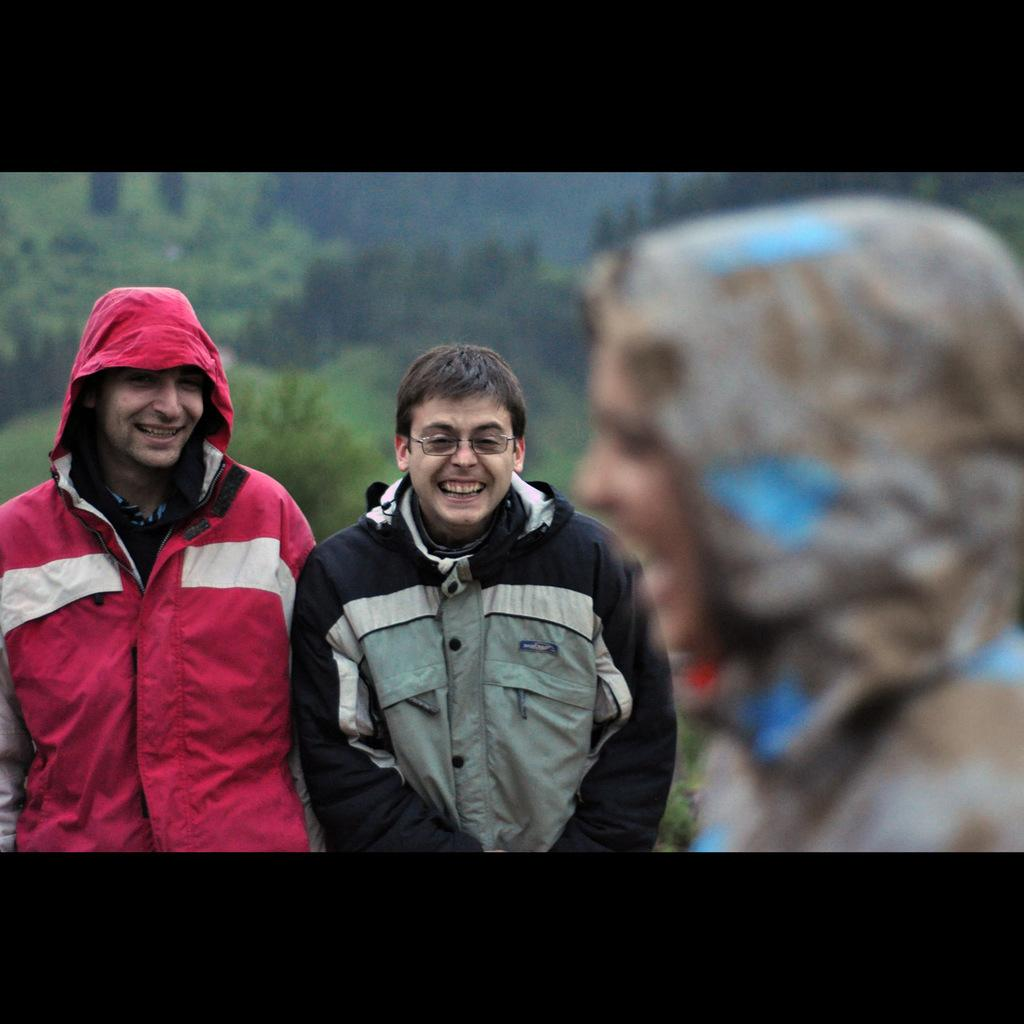How many people are in the image? There are three persons in the image. What are the expressions on their faces? The three persons are smiling. What are the persons doing in the image? The persons are standing. Can you describe the appearance of the person in front? The person in front is blurred. What date is marked on the calendar in the image? There is no calendar present in the image. What type of cloth is draped over the person in the middle? There is no cloth draped over any of the persons in the image. 